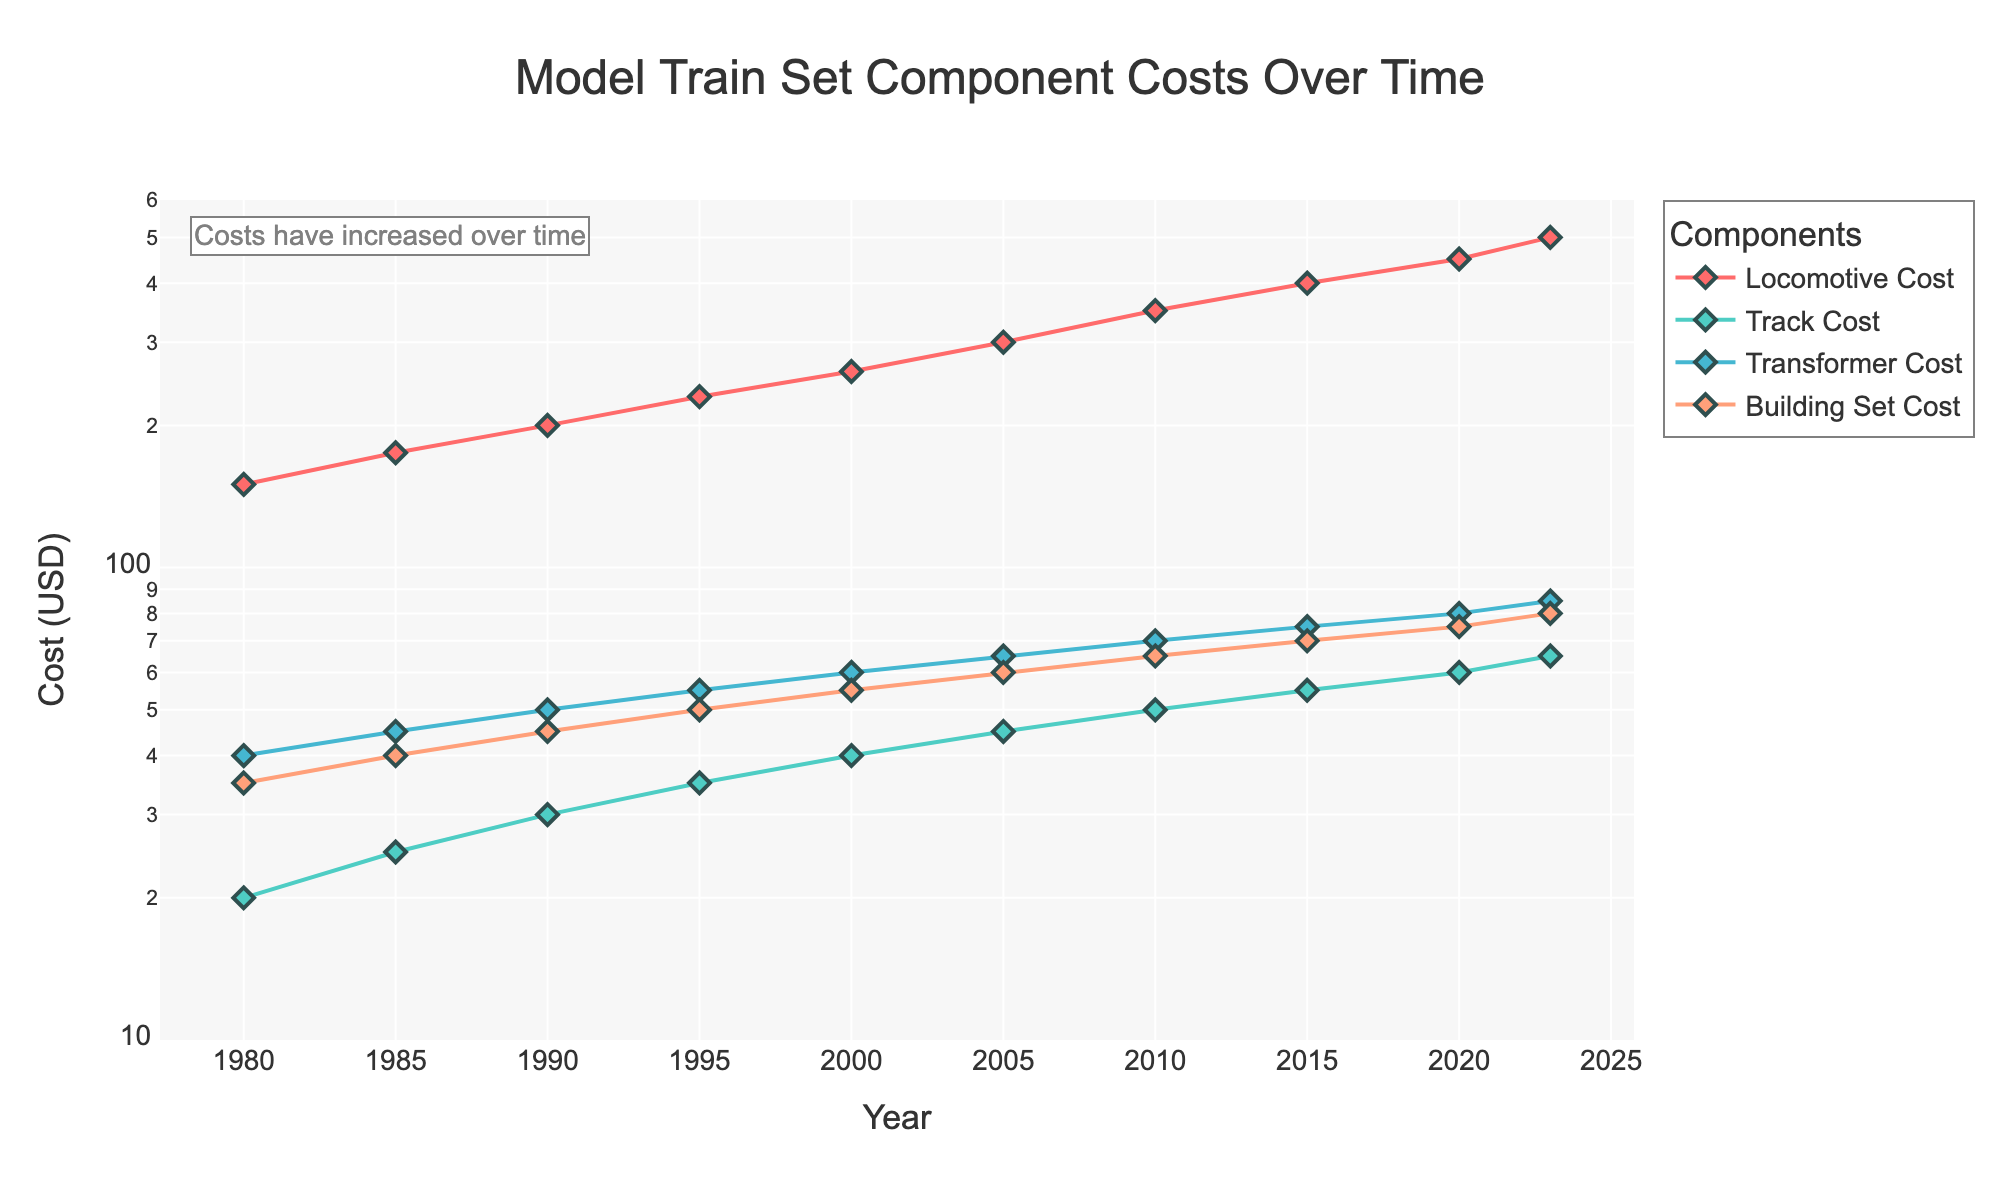How does the cost of locomotives change over time? The plot shows that the cost of locomotives increases steadily over the years, starting from $150 in 1980 to $500 in 2023.
Answer: The cost increases steadily How many data points are there for the year 2000? The x-axis has one data point that aligns with the year 2000 for each of the four components: Locomotive Cost, Track Cost, Transformer Cost, and Building Set Cost.
Answer: Four data points Which component had the highest cost increase by 2023? By observing the figure, the Locomotive Cost shows the highest value at $500 in 2023 compared to other components.
Answer: Locomotive Cost Compare the costs of track and building sets in 1990. Which one is higher and by how much? In 1990, Track Cost is $30 and Building Set Cost is $45. The Building Set Cost is higher by $15.
Answer: Building Set Cost is higher by $15 What's the trend in transformer cost over the years? The Transformer Cost starts at $40 in 1980 and increases steadily to $85 in 2023. This indicates a consistent upward trend.
Answer: Consistent upward trend What was the cost of the building set in 2005? Referring to the plot, the Building Set Cost in 2005 is marked at $60.
Answer: $60 Between which consecutive years does the locomotive cost see the largest increase? The largest increase for the Locomotive Cost happens between 2010 and 2015, where it jumps from $350 to $400, an increase of $50.
Answer: Between 2010 and 2015 How does the y-axis scale help in understanding the trends? The y-axis is on a log scale which helps in visualizing the exponential growth easier to compare percentages of increase over time rather than absolute increases.
Answer: Easier comparison of percentage increases Which year shows the same cost for two different components, if any? In 1985, both Transformer Cost and Building Set Cost are $45 and $40 respectively.
Answer: No year shows the same cost for two different components 